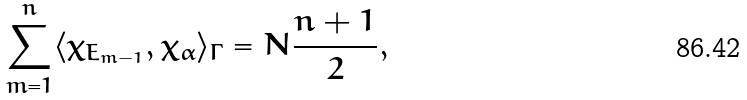<formula> <loc_0><loc_0><loc_500><loc_500>\sum _ { m = 1 } ^ { n } \langle \chi _ { E _ { m - 1 } } , \chi _ { \alpha } \rangle _ { \Gamma } = N \frac { n + 1 } { 2 } ,</formula> 